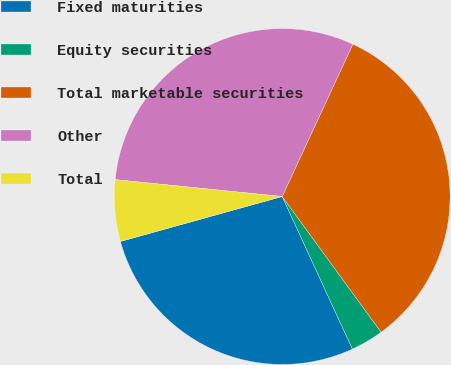Convert chart. <chart><loc_0><loc_0><loc_500><loc_500><pie_chart><fcel>Fixed maturities<fcel>Equity securities<fcel>Total marketable securities<fcel>Other<fcel>Total<nl><fcel>27.55%<fcel>3.16%<fcel>33.06%<fcel>30.31%<fcel>5.92%<nl></chart> 